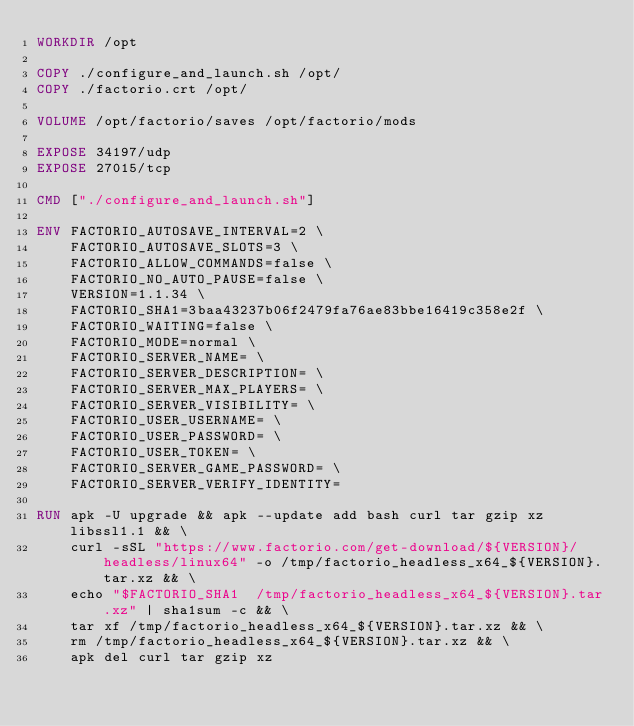<code> <loc_0><loc_0><loc_500><loc_500><_Dockerfile_>WORKDIR /opt

COPY ./configure_and_launch.sh /opt/
COPY ./factorio.crt /opt/

VOLUME /opt/factorio/saves /opt/factorio/mods

EXPOSE 34197/udp
EXPOSE 27015/tcp

CMD ["./configure_and_launch.sh"]

ENV FACTORIO_AUTOSAVE_INTERVAL=2 \
    FACTORIO_AUTOSAVE_SLOTS=3 \
    FACTORIO_ALLOW_COMMANDS=false \
    FACTORIO_NO_AUTO_PAUSE=false \
    VERSION=1.1.34 \
    FACTORIO_SHA1=3baa43237b06f2479fa76ae83bbe16419c358e2f \
    FACTORIO_WAITING=false \
    FACTORIO_MODE=normal \
    FACTORIO_SERVER_NAME= \
    FACTORIO_SERVER_DESCRIPTION= \
    FACTORIO_SERVER_MAX_PLAYERS= \
    FACTORIO_SERVER_VISIBILITY= \
    FACTORIO_USER_USERNAME= \
    FACTORIO_USER_PASSWORD= \
    FACTORIO_USER_TOKEN= \
    FACTORIO_SERVER_GAME_PASSWORD= \
    FACTORIO_SERVER_VERIFY_IDENTITY=

RUN apk -U upgrade && apk --update add bash curl tar gzip xz libssl1.1 && \
    curl -sSL "https://www.factorio.com/get-download/${VERSION}/headless/linux64" -o /tmp/factorio_headless_x64_${VERSION}.tar.xz && \
    echo "$FACTORIO_SHA1  /tmp/factorio_headless_x64_${VERSION}.tar.xz" | sha1sum -c && \
    tar xf /tmp/factorio_headless_x64_${VERSION}.tar.xz && \
    rm /tmp/factorio_headless_x64_${VERSION}.tar.xz && \
    apk del curl tar gzip xz
</code> 